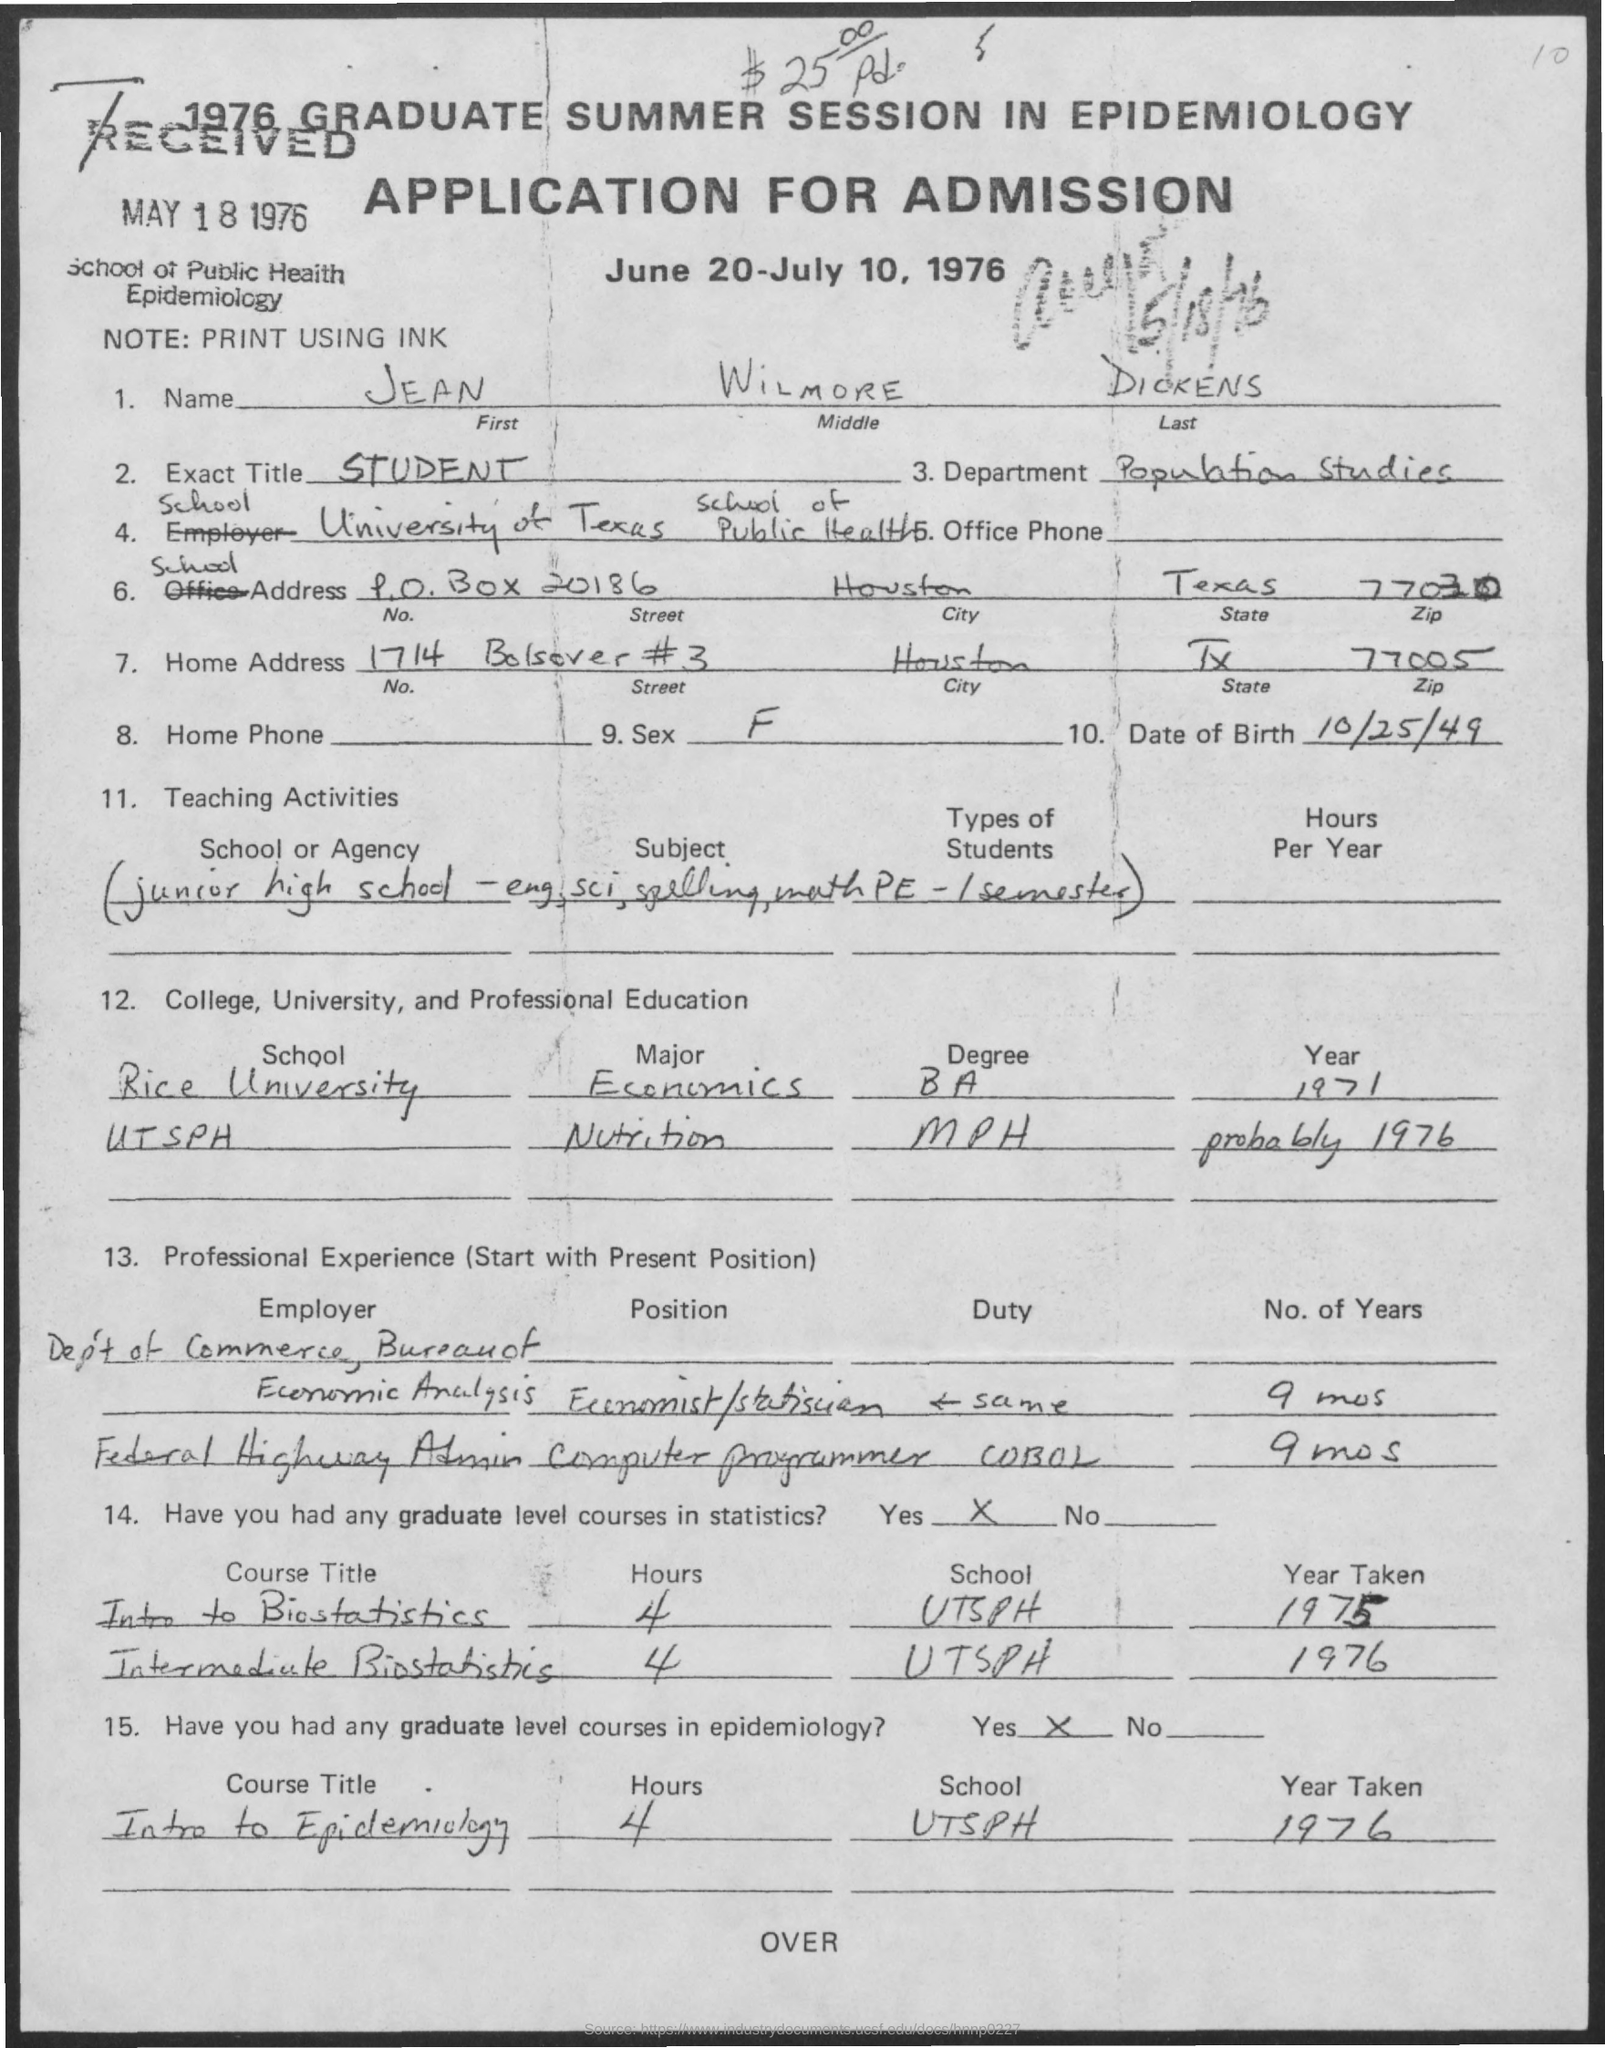what is the exact title mentioned in the given application ? The exact title mentioned in the application image is 'STUDENT'. This title is found in the section of the application designated for the applicant's current status or occupation. 